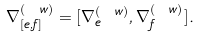Convert formula to latex. <formula><loc_0><loc_0><loc_500><loc_500>\nabla _ { [ e , f ] } ^ { ( \ w ) } = [ \nabla _ { e } ^ { ( \ w ) } , \nabla _ { f } ^ { ( \ w ) } ] .</formula> 